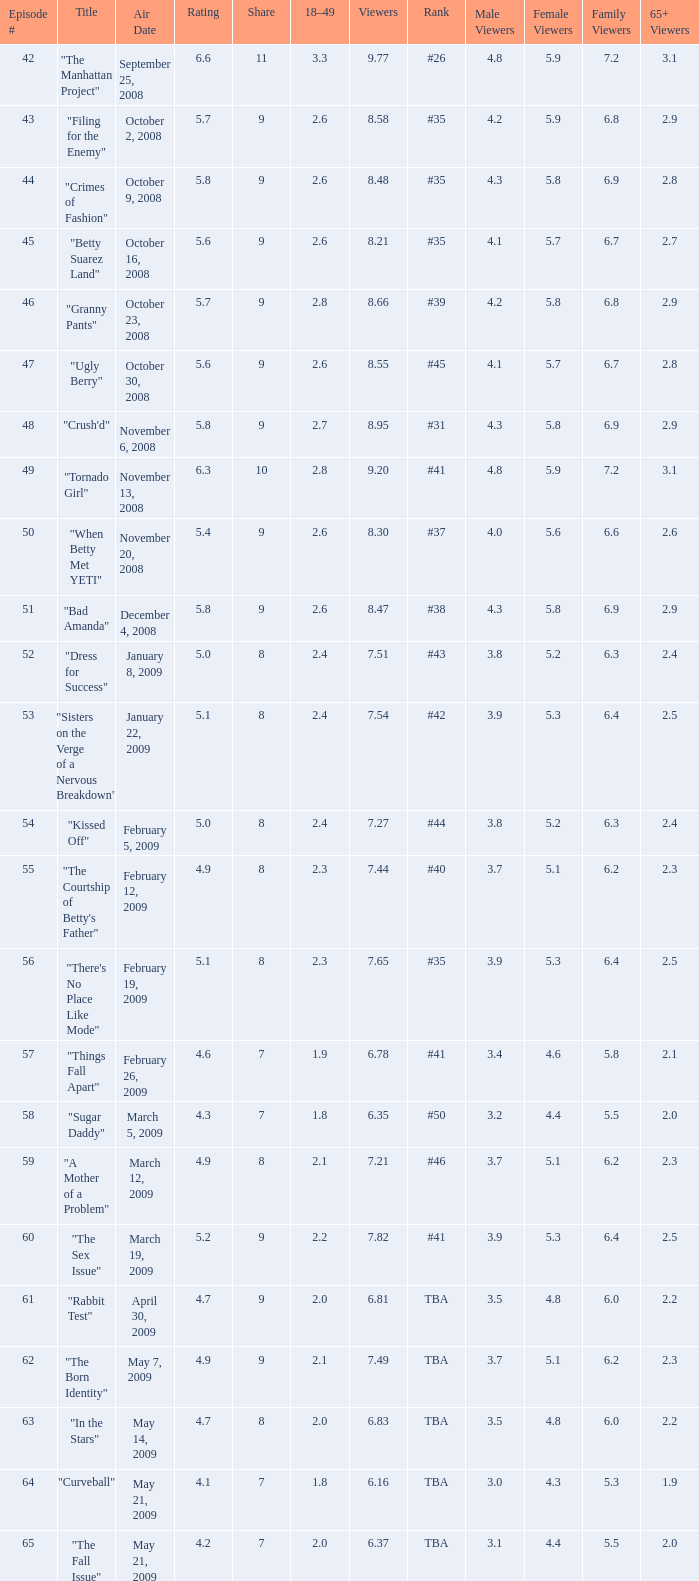What is the lowest Viewers that has an Episode #higher than 58 with a title of "curveball" less than 4.1 rating? None. 